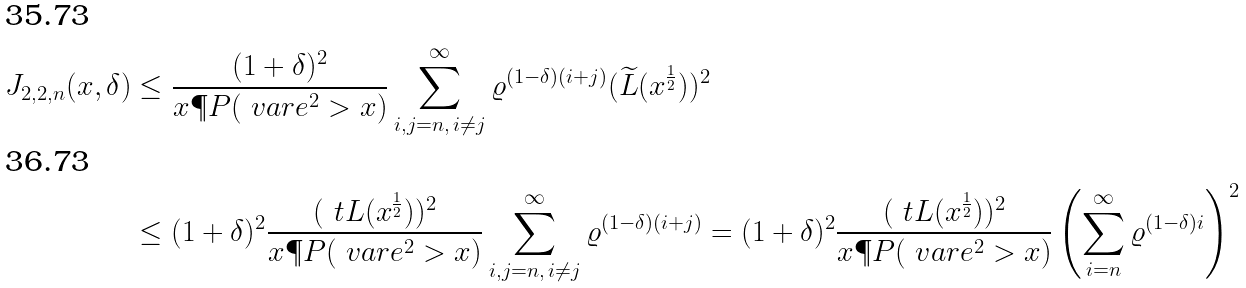<formula> <loc_0><loc_0><loc_500><loc_500>J _ { 2 , 2 , n } ( x , \delta ) & \leq \frac { ( 1 + \delta ) ^ { 2 } } { x \P P ( \ v a r e ^ { 2 } > x ) } \sum _ { i , j = n , \, i \ne j } ^ { \infty } \varrho ^ { ( 1 - \delta ) ( i + j ) } ( \widetilde { L } ( x ^ { \frac { 1 } { 2 } } ) ) ^ { 2 } \\ & \leq ( 1 + \delta ) ^ { 2 } \frac { ( \ t L ( x ^ { \frac { 1 } { 2 } } ) ) ^ { 2 } } { x \P P ( \ v a r e ^ { 2 } > x ) } \sum _ { i , j = n , \, i \ne j } ^ { \infty } \varrho ^ { ( 1 - \delta ) ( i + j ) } = ( 1 + \delta ) ^ { 2 } \frac { ( \ t L ( x ^ { \frac { 1 } { 2 } } ) ) ^ { 2 } } { x \P P ( \ v a r e ^ { 2 } > x ) } \left ( \sum _ { i = n } ^ { \infty } \varrho ^ { ( 1 - \delta ) i } \right ) ^ { 2 }</formula> 